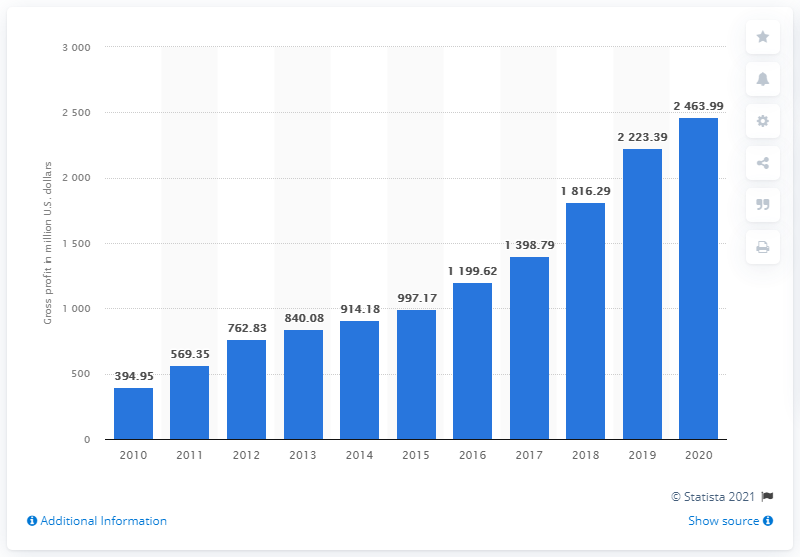Mention a couple of crucial points in this snapshot. The gross profit of lululemon athletica in the financial year of 2020 was 2,463.99. 